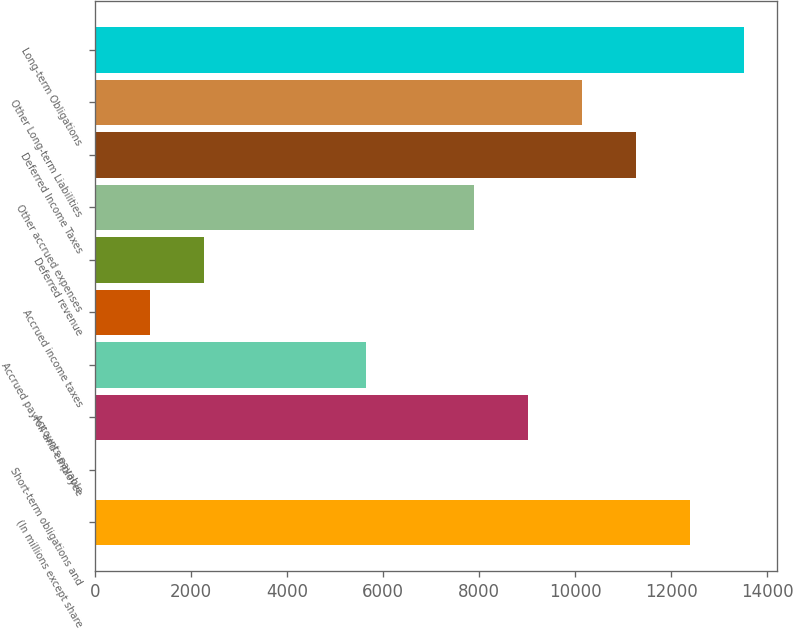Convert chart. <chart><loc_0><loc_0><loc_500><loc_500><bar_chart><fcel>(In millions except share<fcel>Short-term obligations and<fcel>Accounts payable<fcel>Accrued payroll and employee<fcel>Accrued income taxes<fcel>Deferred revenue<fcel>Other accrued expenses<fcel>Deferred Income Taxes<fcel>Other Long-term Liabilities<fcel>Long-term Obligations<nl><fcel>12399<fcel>14.8<fcel>9021.52<fcel>5644<fcel>1140.64<fcel>2266.48<fcel>7895.68<fcel>11273.2<fcel>10147.4<fcel>13524.9<nl></chart> 